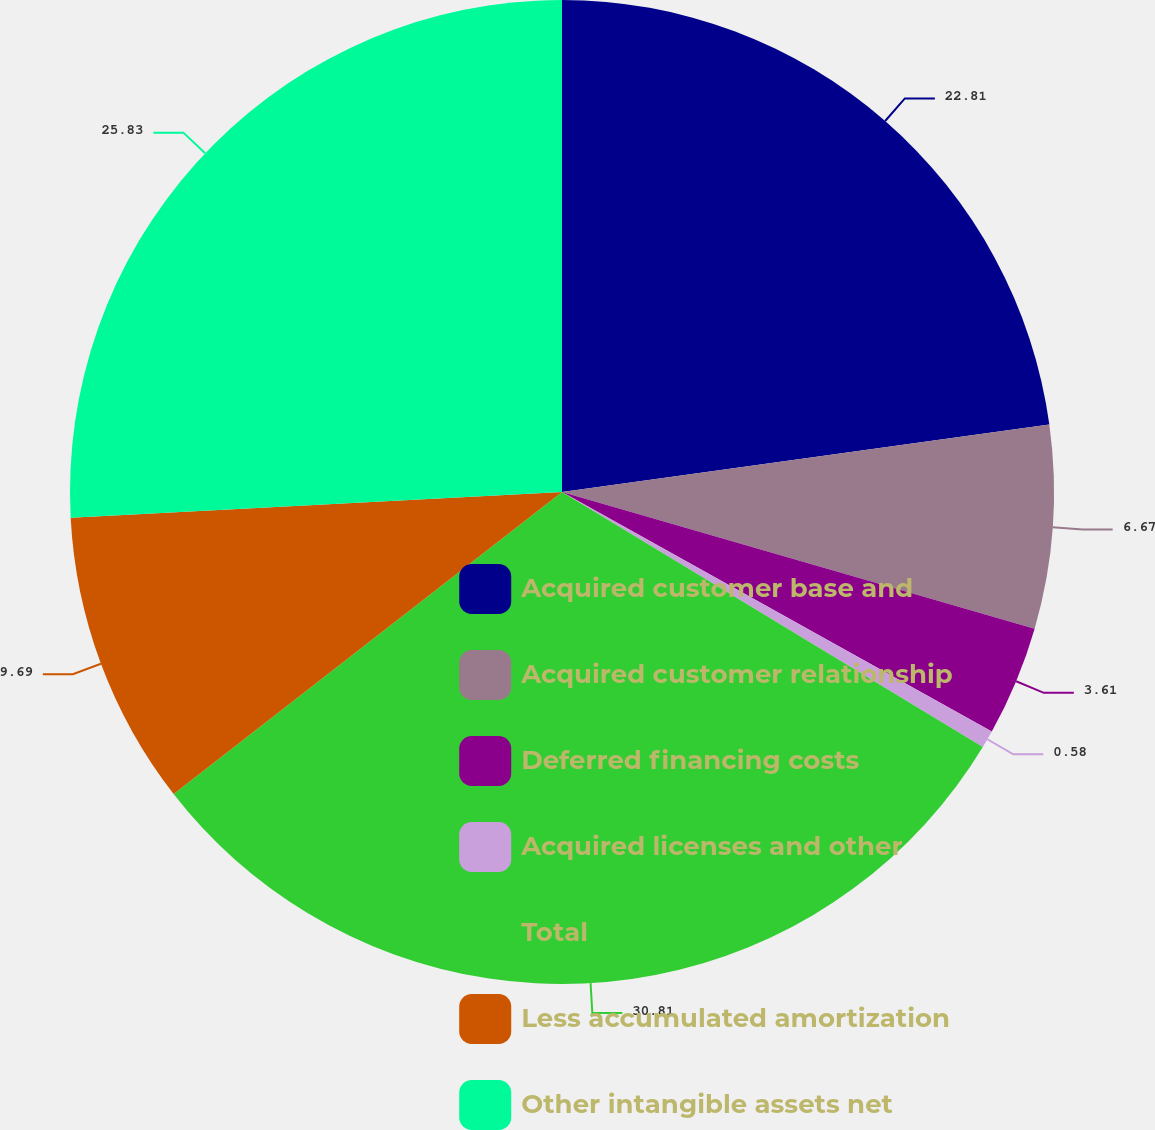<chart> <loc_0><loc_0><loc_500><loc_500><pie_chart><fcel>Acquired customer base and<fcel>Acquired customer relationship<fcel>Deferred financing costs<fcel>Acquired licenses and other<fcel>Total<fcel>Less accumulated amortization<fcel>Other intangible assets net<nl><fcel>22.81%<fcel>6.67%<fcel>3.61%<fcel>0.58%<fcel>30.81%<fcel>9.69%<fcel>25.83%<nl></chart> 